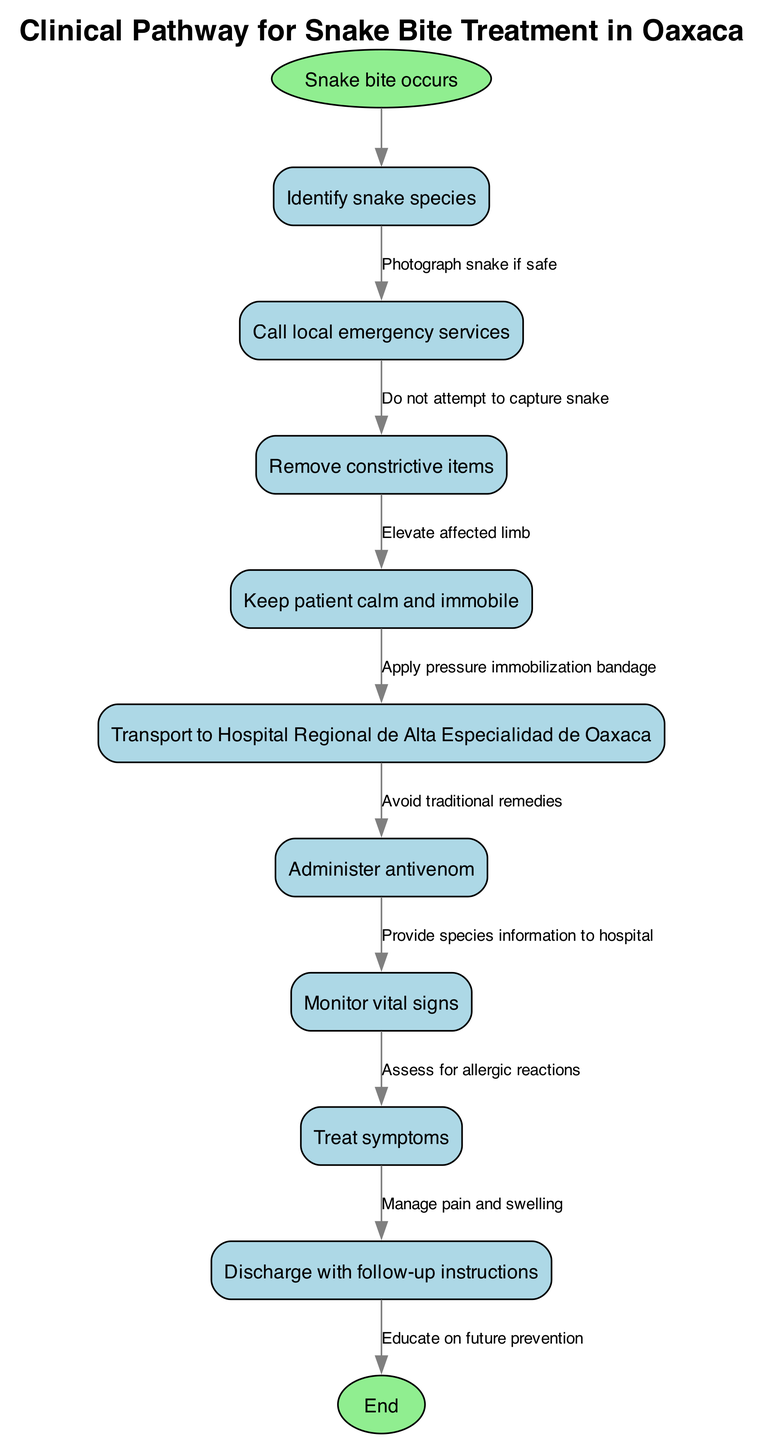What is the first action to take when a snake bite occurs? The first node in the pathway is "Identify snake species." This is directly connected to the starting event "Snake bite occurs." Therefore, it is the initial step following the occurrence of a snake bite.
Answer: Identify snake species How many edges are there in the clinical pathway? By counting the edges in the diagram, it's determined that there are a total of eight edges connecting the steps in the clinical pathway.
Answer: Eight What action should be taken after administering antivenom? The next node after "Administer antivenom" is "Monitor vital signs." This shows the sequence of actions that must occur after the administration of antivenom.
Answer: Monitor vital signs What is the last step before discharge? The final node before reaching "Discharge with follow-up instructions" is "Treat symptoms," indicating that symptom treatment is essential before the patient is discharged.
Answer: Treat symptoms Which node emphasizes the importance of patient emotion during the treatment? "Keep patient calm and immobile" focuses on the emotional state of the patient and is essential in managing the reaction to the snake bite and the treatment process.
Answer: Keep patient calm and immobile What should be done regarding the snake if it is safe to do so? The diagram states "Photograph snake if safe," indicating that this action is acceptable and recommended when safe conditions are met.
Answer: Photograph snake if safe Which step instructs against traditional remedies? The node "Avoid traditional remedies" explicitly instructs not to use traditional treatments, highlighting a crucial cautionary step in the pathway.
Answer: Avoid traditional remedies How is allergic reaction to antivenom assessed? After administering antivenom, "Assess for allergic reactions" is the next action to take, directly indicating the need to monitor for possible allergic responses.
Answer: Assess for allergic reactions 